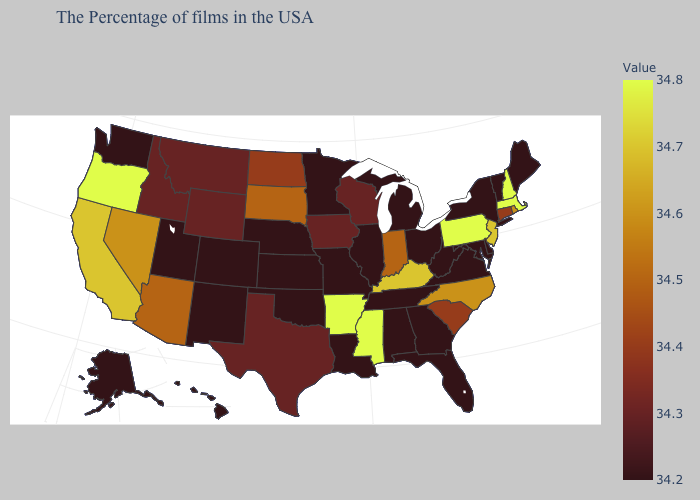Which states hav the highest value in the Northeast?
Write a very short answer. Massachusetts, New Hampshire, Pennsylvania. Which states have the lowest value in the MidWest?
Short answer required. Ohio, Michigan, Illinois, Missouri, Minnesota, Kansas, Nebraska. Does Tennessee have a higher value than North Carolina?
Quick response, please. No. Does the map have missing data?
Answer briefly. No. Does South Dakota have the highest value in the MidWest?
Quick response, please. Yes. 